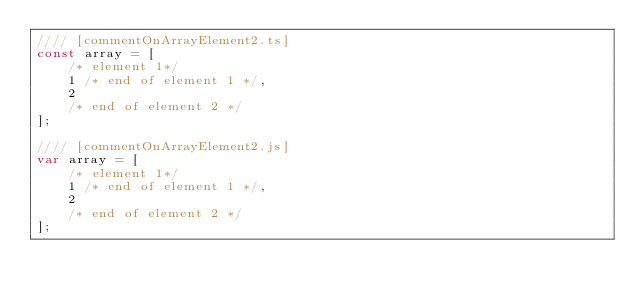Convert code to text. <code><loc_0><loc_0><loc_500><loc_500><_JavaScript_>//// [commentOnArrayElement2.ts]
const array = [
    /* element 1*/
    1 /* end of element 1 */,
    2
    /* end of element 2 */
];

//// [commentOnArrayElement2.js]
var array = [
    /* element 1*/
    1 /* end of element 1 */,
    2
    /* end of element 2 */
];
</code> 